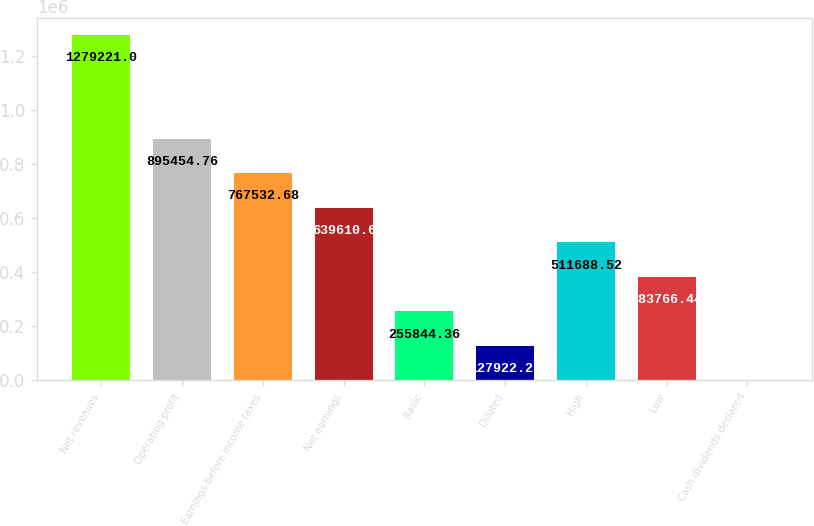Convert chart to OTSL. <chart><loc_0><loc_0><loc_500><loc_500><bar_chart><fcel>Net revenues<fcel>Operating profit<fcel>Earnings before income taxes<fcel>Net earnings<fcel>Basic<fcel>Diluted<fcel>High<fcel>Low<fcel>Cash dividends declared<nl><fcel>1.27922e+06<fcel>895455<fcel>767533<fcel>639611<fcel>255844<fcel>127922<fcel>511689<fcel>383766<fcel>0.2<nl></chart> 